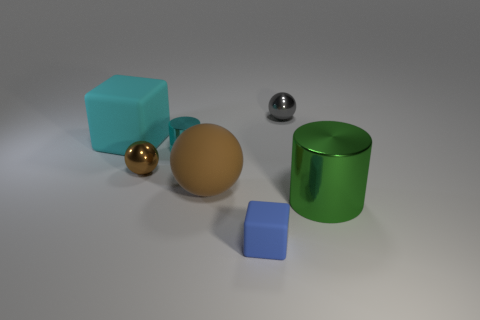Is the number of large green shiny cylinders less than the number of big brown metallic cylinders?
Provide a succinct answer. No. There is a small shiny ball that is on the left side of the gray object; does it have the same color as the big metal cylinder?
Ensure brevity in your answer.  No. What color is the sphere that is made of the same material as the small blue cube?
Provide a succinct answer. Brown. Do the brown shiny object and the gray object have the same size?
Your answer should be very brief. Yes. What is the material of the large cube?
Offer a terse response. Rubber. There is a block that is the same size as the gray ball; what is it made of?
Offer a very short reply. Rubber. Is there a cyan matte ball of the same size as the cyan rubber block?
Keep it short and to the point. No. Is the number of tiny rubber things that are on the right side of the green metallic cylinder the same as the number of small cyan things that are behind the small brown object?
Give a very brief answer. No. Are there more small things than small cyan cylinders?
Ensure brevity in your answer.  Yes. How many metal objects are red cylinders or tiny blue things?
Provide a short and direct response. 0. 